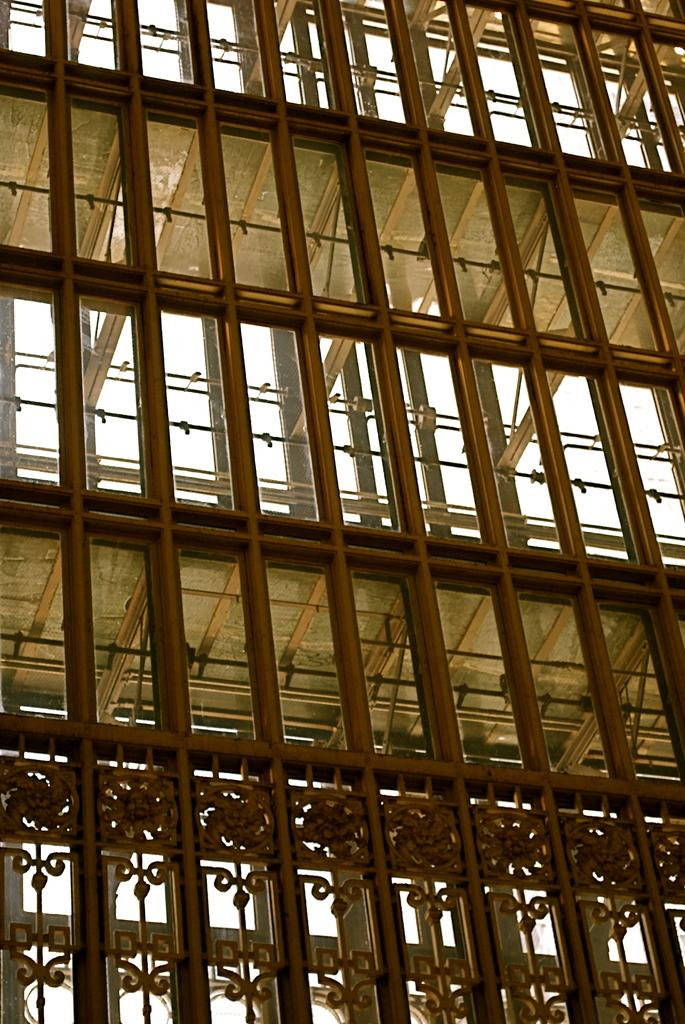What type of architectural feature can be seen in the image? There are iron grilles in the image. What material is used for the windows in the image? There are glass windows in the image. What book is being waved good-bye to in the image? There is no book or motion of good-bye present in the image. 